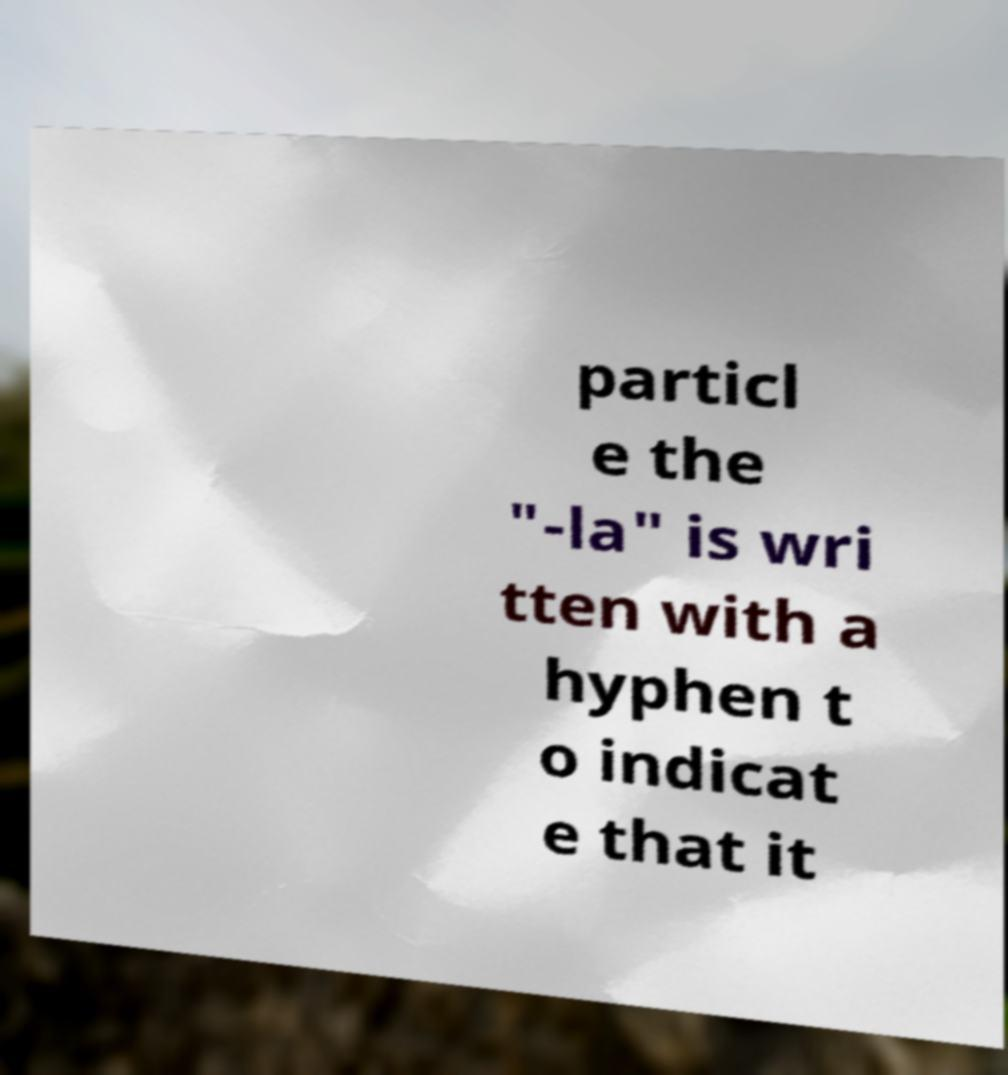I need the written content from this picture converted into text. Can you do that? particl e the "-la" is wri tten with a hyphen t o indicat e that it 